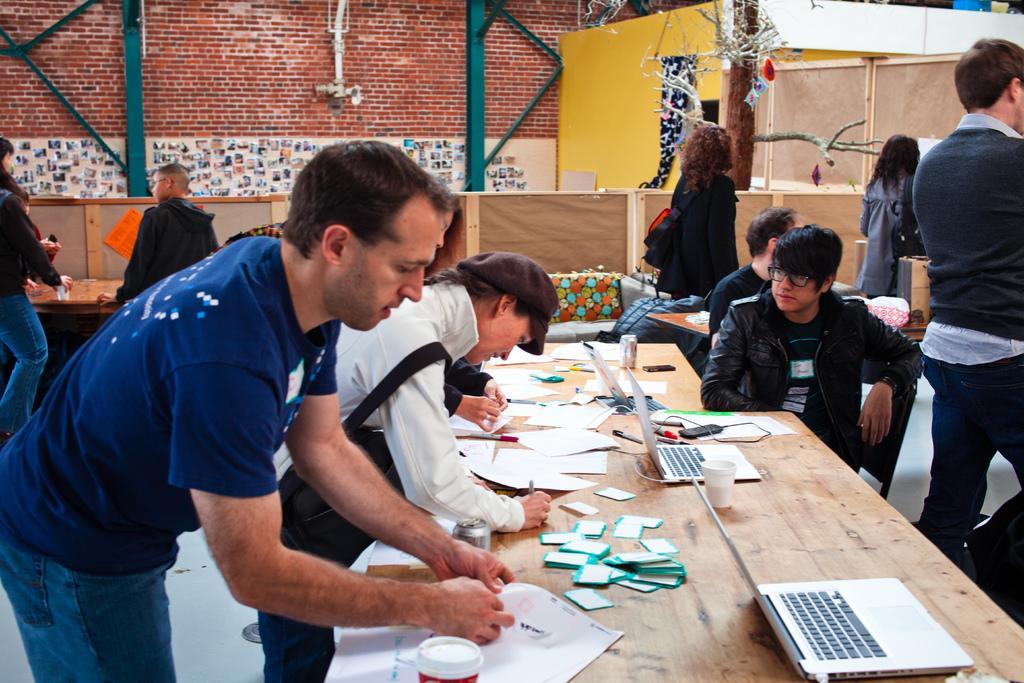In one or two sentences, can you explain what this image depicts? In this image we can see a few people standing and a few people are sitting on the chairs in front of the tables. On the tables we can see the papers, laptops, mobile phones, paper glass, coke tins and some other objects. We can also see the wall. In the background we can see the buildings and also the tree. We can also see the surface. 